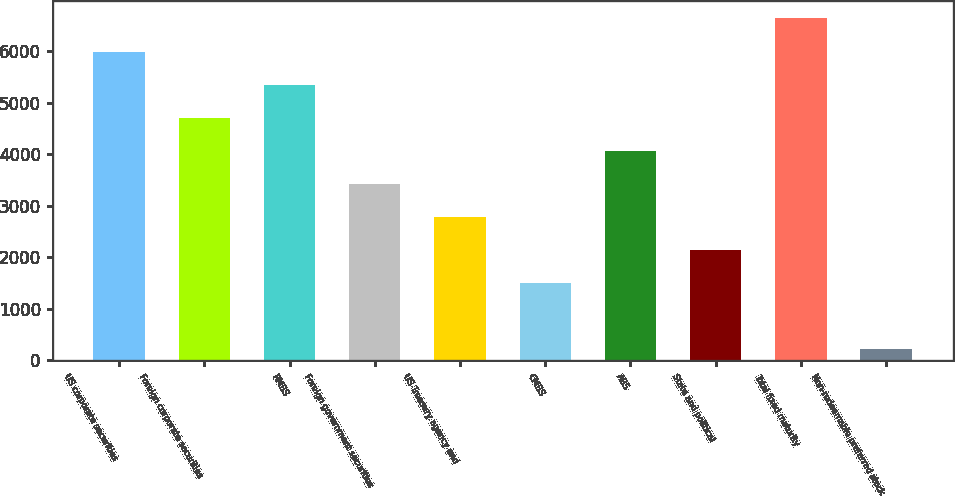Convert chart to OTSL. <chart><loc_0><loc_0><loc_500><loc_500><bar_chart><fcel>US corporate securities<fcel>Foreign corporate securities<fcel>RMBS<fcel>Foreign government securities<fcel>US Treasury agency and<fcel>CMBS<fcel>ABS<fcel>State and political<fcel>Total fixed maturity<fcel>Non-redeemable preferred stock<nl><fcel>5990.8<fcel>4710.4<fcel>5350.6<fcel>3430<fcel>2789.8<fcel>1509.4<fcel>4070.2<fcel>2149.6<fcel>6631<fcel>229<nl></chart> 